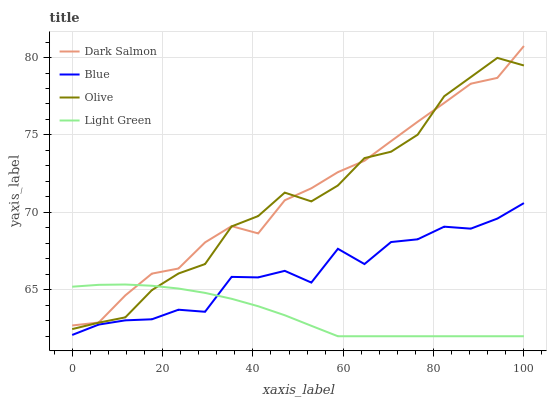Does Light Green have the minimum area under the curve?
Answer yes or no. Yes. Does Dark Salmon have the maximum area under the curve?
Answer yes or no. Yes. Does Olive have the minimum area under the curve?
Answer yes or no. No. Does Olive have the maximum area under the curve?
Answer yes or no. No. Is Light Green the smoothest?
Answer yes or no. Yes. Is Blue the roughest?
Answer yes or no. Yes. Is Olive the smoothest?
Answer yes or no. No. Is Olive the roughest?
Answer yes or no. No. Does Light Green have the lowest value?
Answer yes or no. Yes. Does Olive have the lowest value?
Answer yes or no. No. Does Dark Salmon have the highest value?
Answer yes or no. Yes. Does Olive have the highest value?
Answer yes or no. No. Is Blue less than Olive?
Answer yes or no. Yes. Is Olive greater than Blue?
Answer yes or no. Yes. Does Olive intersect Dark Salmon?
Answer yes or no. Yes. Is Olive less than Dark Salmon?
Answer yes or no. No. Is Olive greater than Dark Salmon?
Answer yes or no. No. Does Blue intersect Olive?
Answer yes or no. No. 